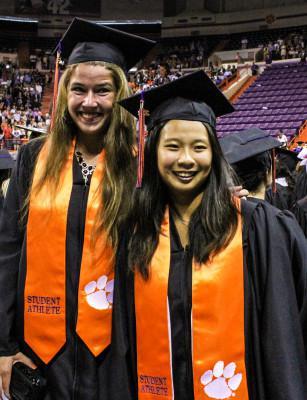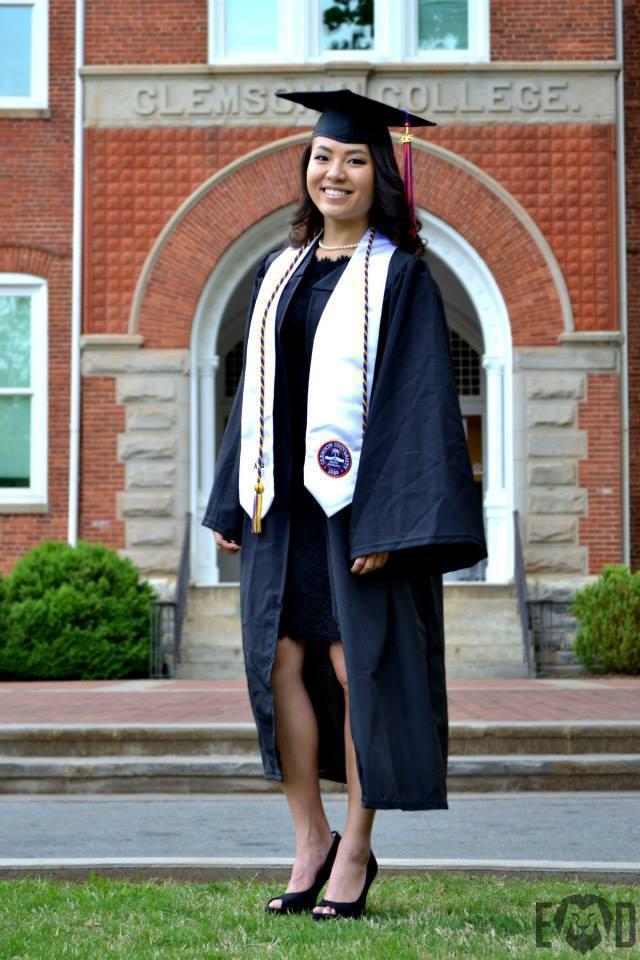The first image is the image on the left, the second image is the image on the right. Given the left and right images, does the statement "One image includes at least two female graduates wearing black caps and robes with orange sashes, and the other image shows only one person in a graduate robe in the foreground." hold true? Answer yes or no. Yes. The first image is the image on the left, the second image is the image on the right. Given the left and right images, does the statement "There are at least two women wearing orange sashes." hold true? Answer yes or no. Yes. 